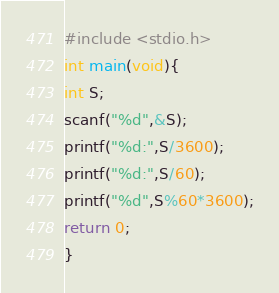<code> <loc_0><loc_0><loc_500><loc_500><_C_>#include <stdio.h>
int main(void){
int S;
scanf("%d",&S);
printf("%d:",S/3600);
printf("%d:",S/60);
printf("%d",S%60*3600);
return 0;
}</code> 